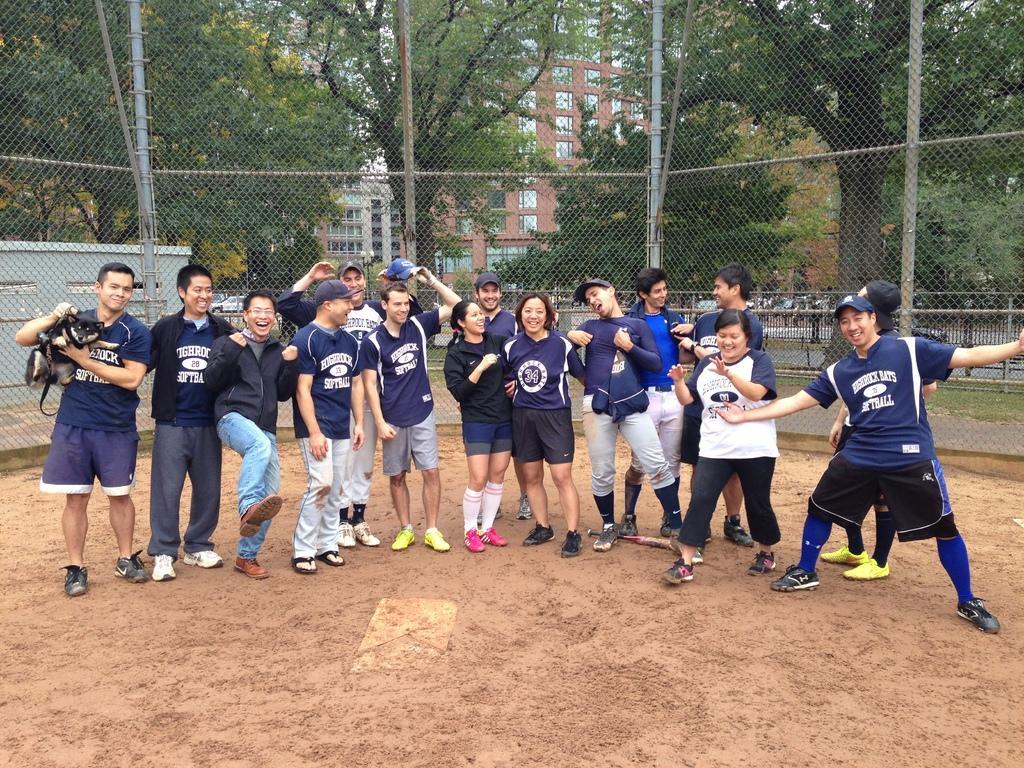Please provide a concise description of this image. In this image, we can see a group of people are standing on the ground. They are smiling. Here we can see a person is holding a dog. Few are wearing caps. Background we can see mesh, rods, pole, so many trees, buildings, some shed here. 